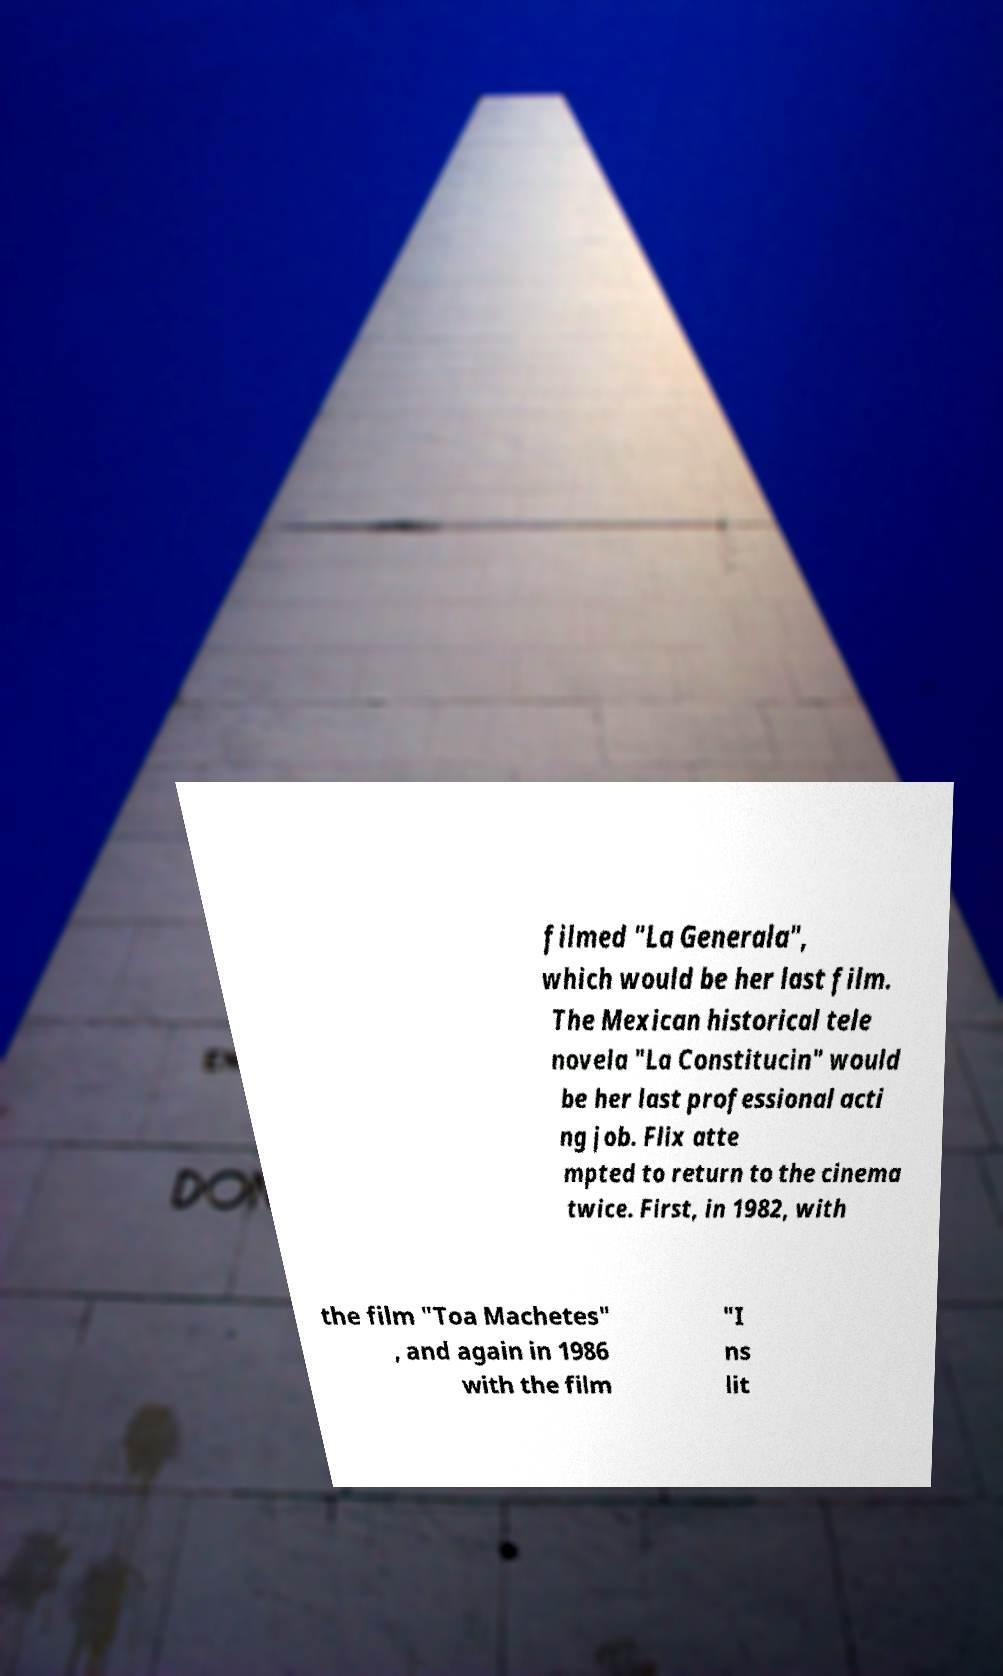For documentation purposes, I need the text within this image transcribed. Could you provide that? filmed "La Generala", which would be her last film. The Mexican historical tele novela "La Constitucin" would be her last professional acti ng job. Flix atte mpted to return to the cinema twice. First, in 1982, with the film "Toa Machetes" , and again in 1986 with the film "I ns lit 